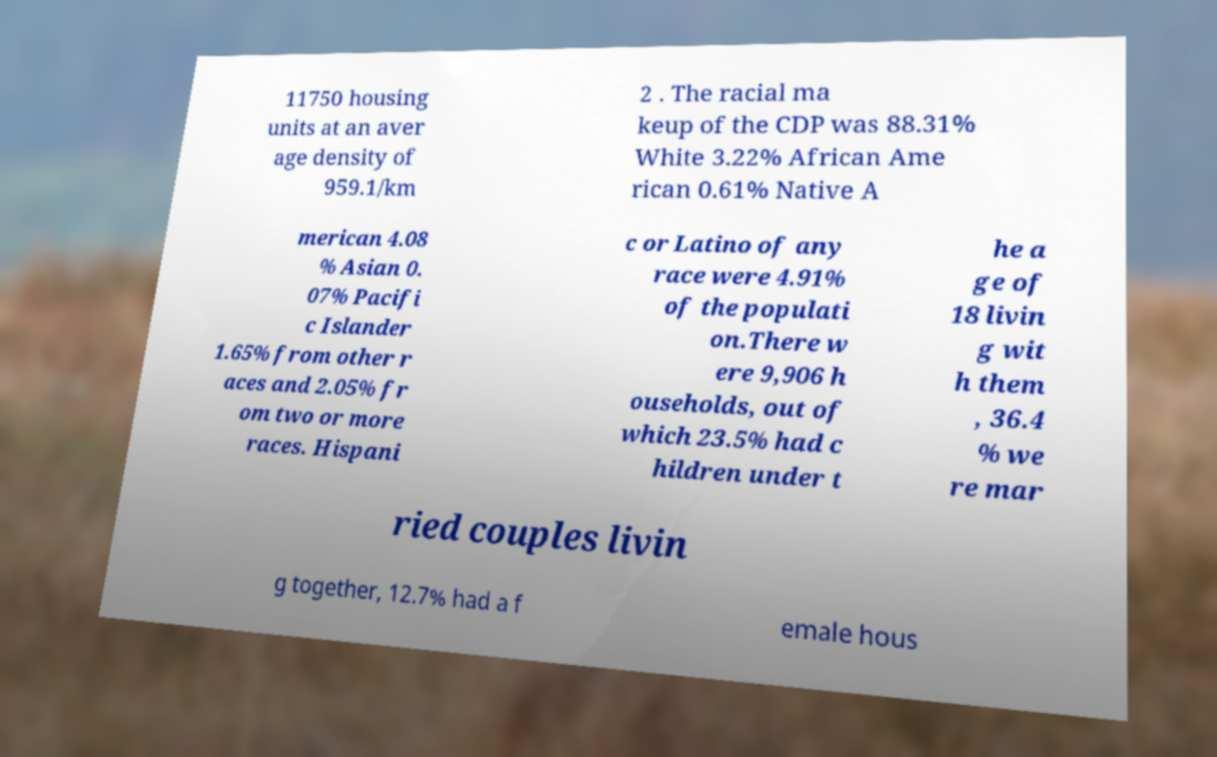Please identify and transcribe the text found in this image. 11750 housing units at an aver age density of 959.1/km 2 . The racial ma keup of the CDP was 88.31% White 3.22% African Ame rican 0.61% Native A merican 4.08 % Asian 0. 07% Pacifi c Islander 1.65% from other r aces and 2.05% fr om two or more races. Hispani c or Latino of any race were 4.91% of the populati on.There w ere 9,906 h ouseholds, out of which 23.5% had c hildren under t he a ge of 18 livin g wit h them , 36.4 % we re mar ried couples livin g together, 12.7% had a f emale hous 